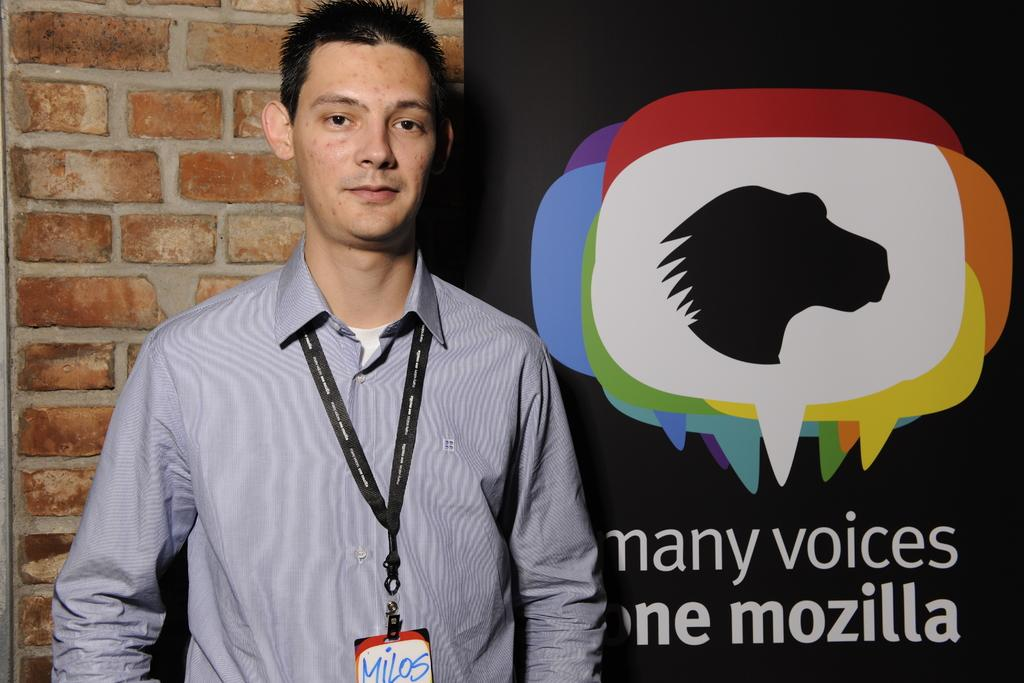What is the main subject of the image? The main subject of the image is a man standing. Can you describe what the man is wearing around his neck? The man is wearing an ID card around his neck. What can be seen in the background of the image? There is a wall and a hoarding in the background of the image. What type of verse can be seen written on the wall in the image? There is no verse visible on the wall in the image. Is the man in the image applying the brake on his bicycle? There is no bicycle present in the image, so it is not possible to determine if the man is applying the brake. 